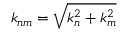<formula> <loc_0><loc_0><loc_500><loc_500>k _ { n m } = \sqrt { k _ { n } ^ { 2 } + k _ { m } ^ { 2 } }</formula> 